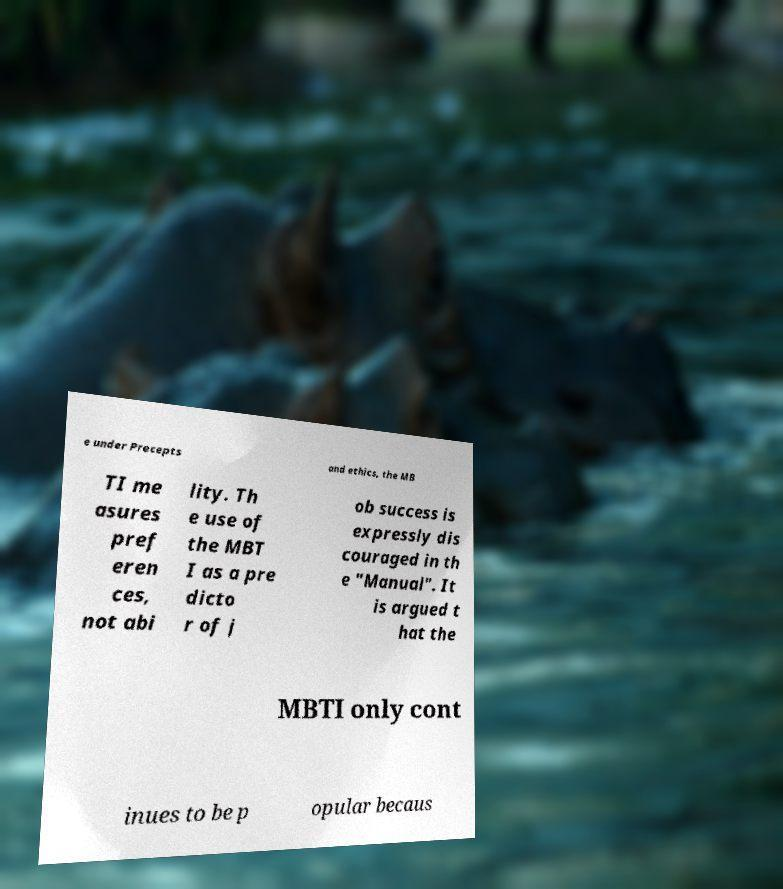There's text embedded in this image that I need extracted. Can you transcribe it verbatim? e under Precepts and ethics, the MB TI me asures pref eren ces, not abi lity. Th e use of the MBT I as a pre dicto r of j ob success is expressly dis couraged in th e "Manual". It is argued t hat the MBTI only cont inues to be p opular becaus 